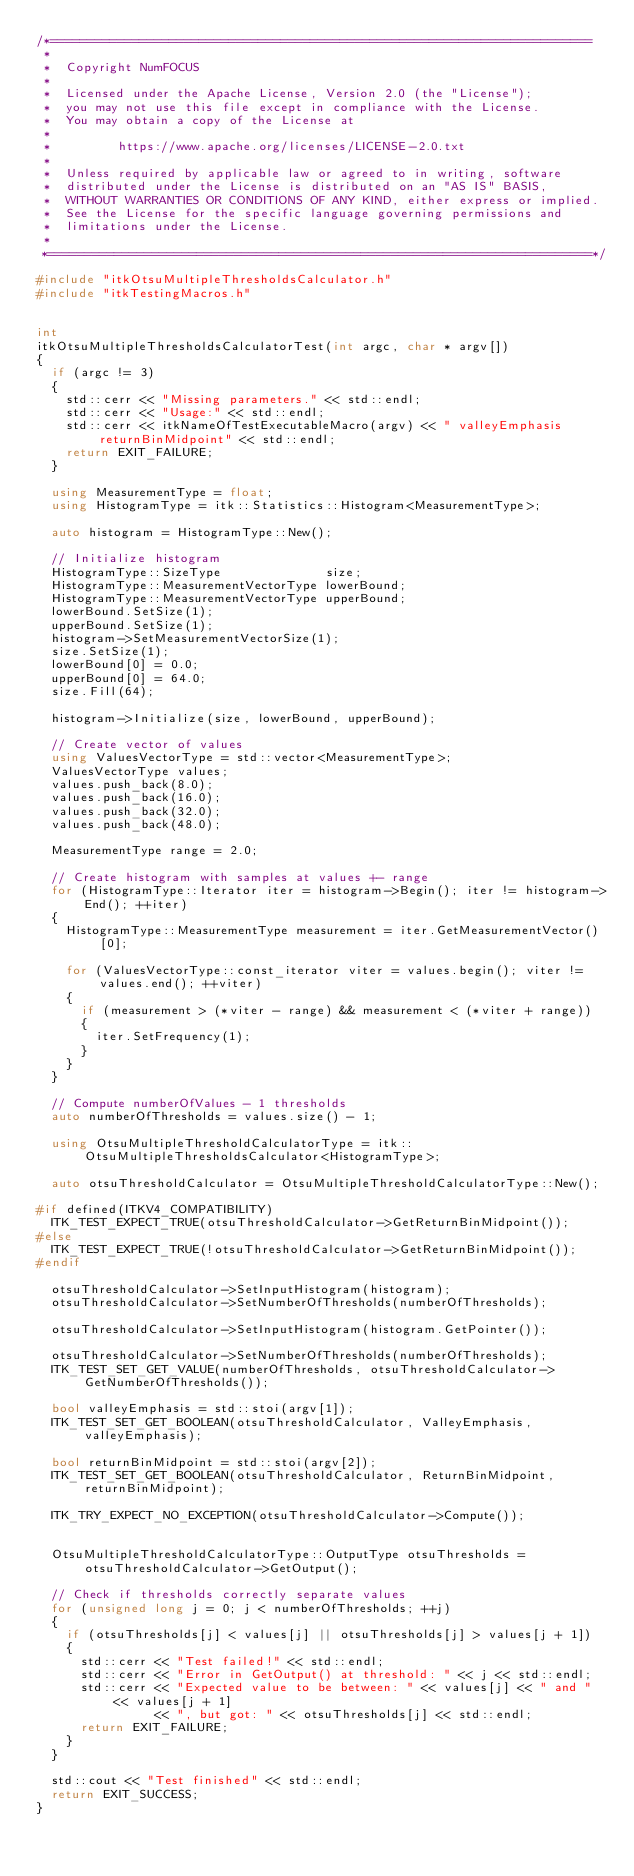<code> <loc_0><loc_0><loc_500><loc_500><_C++_>/*=========================================================================
 *
 *  Copyright NumFOCUS
 *
 *  Licensed under the Apache License, Version 2.0 (the "License");
 *  you may not use this file except in compliance with the License.
 *  You may obtain a copy of the License at
 *
 *         https://www.apache.org/licenses/LICENSE-2.0.txt
 *
 *  Unless required by applicable law or agreed to in writing, software
 *  distributed under the License is distributed on an "AS IS" BASIS,
 *  WITHOUT WARRANTIES OR CONDITIONS OF ANY KIND, either express or implied.
 *  See the License for the specific language governing permissions and
 *  limitations under the License.
 *
 *=========================================================================*/

#include "itkOtsuMultipleThresholdsCalculator.h"
#include "itkTestingMacros.h"


int
itkOtsuMultipleThresholdsCalculatorTest(int argc, char * argv[])
{
  if (argc != 3)
  {
    std::cerr << "Missing parameters." << std::endl;
    std::cerr << "Usage:" << std::endl;
    std::cerr << itkNameOfTestExecutableMacro(argv) << " valleyEmphasis returnBinMidpoint" << std::endl;
    return EXIT_FAILURE;
  }

  using MeasurementType = float;
  using HistogramType = itk::Statistics::Histogram<MeasurementType>;

  auto histogram = HistogramType::New();

  // Initialize histogram
  HistogramType::SizeType              size;
  HistogramType::MeasurementVectorType lowerBound;
  HistogramType::MeasurementVectorType upperBound;
  lowerBound.SetSize(1);
  upperBound.SetSize(1);
  histogram->SetMeasurementVectorSize(1);
  size.SetSize(1);
  lowerBound[0] = 0.0;
  upperBound[0] = 64.0;
  size.Fill(64);

  histogram->Initialize(size, lowerBound, upperBound);

  // Create vector of values
  using ValuesVectorType = std::vector<MeasurementType>;
  ValuesVectorType values;
  values.push_back(8.0);
  values.push_back(16.0);
  values.push_back(32.0);
  values.push_back(48.0);

  MeasurementType range = 2.0;

  // Create histogram with samples at values +- range
  for (HistogramType::Iterator iter = histogram->Begin(); iter != histogram->End(); ++iter)
  {
    HistogramType::MeasurementType measurement = iter.GetMeasurementVector()[0];

    for (ValuesVectorType::const_iterator viter = values.begin(); viter != values.end(); ++viter)
    {
      if (measurement > (*viter - range) && measurement < (*viter + range))
      {
        iter.SetFrequency(1);
      }
    }
  }

  // Compute numberOfValues - 1 thresholds
  auto numberOfThresholds = values.size() - 1;

  using OtsuMultipleThresholdCalculatorType = itk::OtsuMultipleThresholdsCalculator<HistogramType>;

  auto otsuThresholdCalculator = OtsuMultipleThresholdCalculatorType::New();

#if defined(ITKV4_COMPATIBILITY)
  ITK_TEST_EXPECT_TRUE(otsuThresholdCalculator->GetReturnBinMidpoint());
#else
  ITK_TEST_EXPECT_TRUE(!otsuThresholdCalculator->GetReturnBinMidpoint());
#endif

  otsuThresholdCalculator->SetInputHistogram(histogram);
  otsuThresholdCalculator->SetNumberOfThresholds(numberOfThresholds);

  otsuThresholdCalculator->SetInputHistogram(histogram.GetPointer());

  otsuThresholdCalculator->SetNumberOfThresholds(numberOfThresholds);
  ITK_TEST_SET_GET_VALUE(numberOfThresholds, otsuThresholdCalculator->GetNumberOfThresholds());

  bool valleyEmphasis = std::stoi(argv[1]);
  ITK_TEST_SET_GET_BOOLEAN(otsuThresholdCalculator, ValleyEmphasis, valleyEmphasis);

  bool returnBinMidpoint = std::stoi(argv[2]);
  ITK_TEST_SET_GET_BOOLEAN(otsuThresholdCalculator, ReturnBinMidpoint, returnBinMidpoint);

  ITK_TRY_EXPECT_NO_EXCEPTION(otsuThresholdCalculator->Compute());


  OtsuMultipleThresholdCalculatorType::OutputType otsuThresholds = otsuThresholdCalculator->GetOutput();

  // Check if thresholds correctly separate values
  for (unsigned long j = 0; j < numberOfThresholds; ++j)
  {
    if (otsuThresholds[j] < values[j] || otsuThresholds[j] > values[j + 1])
    {
      std::cerr << "Test failed!" << std::endl;
      std::cerr << "Error in GetOutput() at threshold: " << j << std::endl;
      std::cerr << "Expected value to be between: " << values[j] << " and " << values[j + 1]
                << ", but got: " << otsuThresholds[j] << std::endl;
      return EXIT_FAILURE;
    }
  }

  std::cout << "Test finished" << std::endl;
  return EXIT_SUCCESS;
}
</code> 